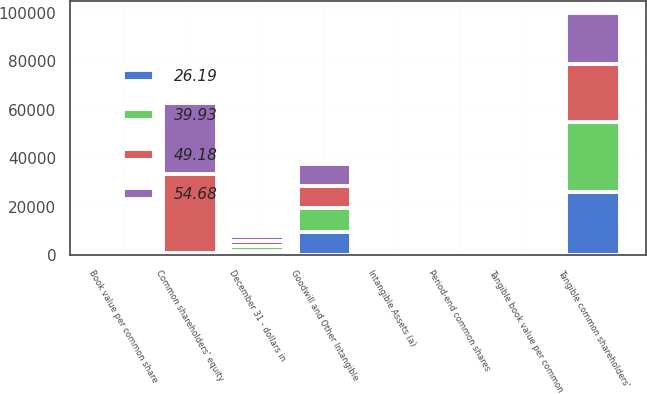Convert chart. <chart><loc_0><loc_0><loc_500><loc_500><stacked_bar_chart><ecel><fcel>December 31 - dollars in<fcel>Book value per common share<fcel>Common shareholders' equity<fcel>Goodwill and Other Intangible<fcel>Intangible Assets (a)<fcel>Tangible common shareholders'<fcel>Period-end common shares<fcel>Tangible book value per common<nl><fcel>39.93<fcel>2013<fcel>72.21<fcel>530.5<fcel>9654<fcel>333<fcel>29146<fcel>533<fcel>54.68<nl><fcel>26.19<fcel>2012<fcel>67.05<fcel>530.5<fcel>9798<fcel>354<fcel>25969<fcel>528<fcel>49.18<nl><fcel>49.18<fcel>2011<fcel>61.52<fcel>32417<fcel>9027<fcel>431<fcel>23821<fcel>527<fcel>45.2<nl><fcel>54.68<fcel>2010<fcel>56.29<fcel>29596<fcel>9052<fcel>461<fcel>21005<fcel>526<fcel>39.93<nl></chart> 